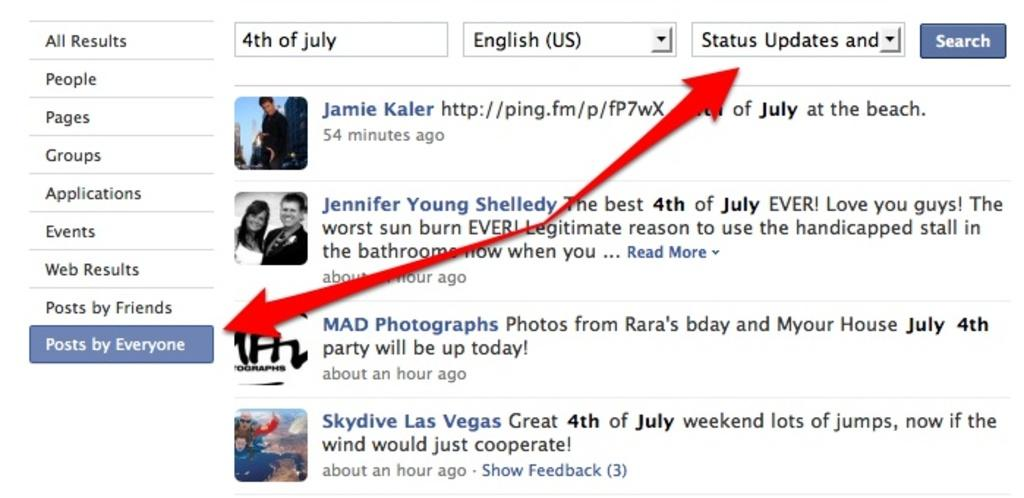What type of content is displayed in the image? There is a web page in the image. What can be found on the web page? The web page contains text and pictures of some persons. Are there any visual elements used to guide the viewer on the web page? Yes, red color arrows are present on the web page. What type of jam is being sung about in the image? There is no jam or song present in the image; it features a web page with text and pictures of persons. 